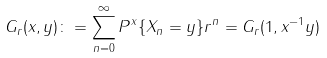Convert formula to latex. <formula><loc_0><loc_0><loc_500><loc_500>G _ { r } ( x , y ) \colon = \sum _ { n = 0 } ^ { \infty } P ^ { x } \{ X _ { n } = y \} r ^ { n } = G _ { r } ( 1 , x ^ { - 1 } y )</formula> 